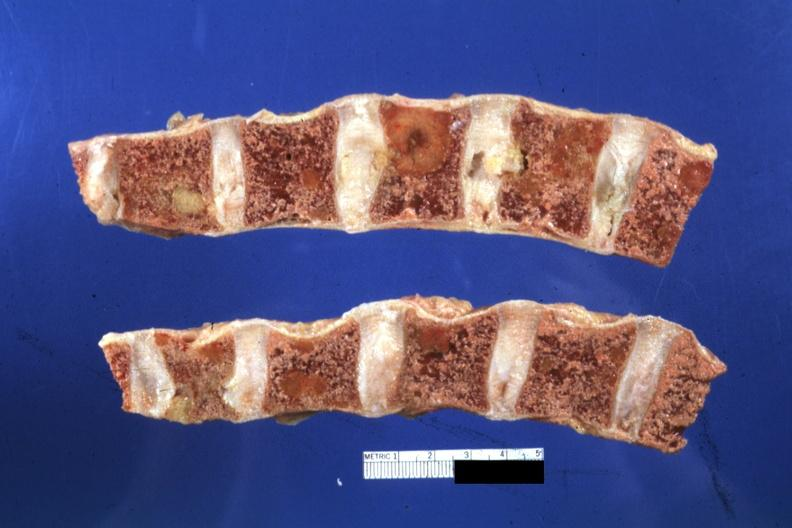s color off?
Answer the question using a single word or phrase. Yes 